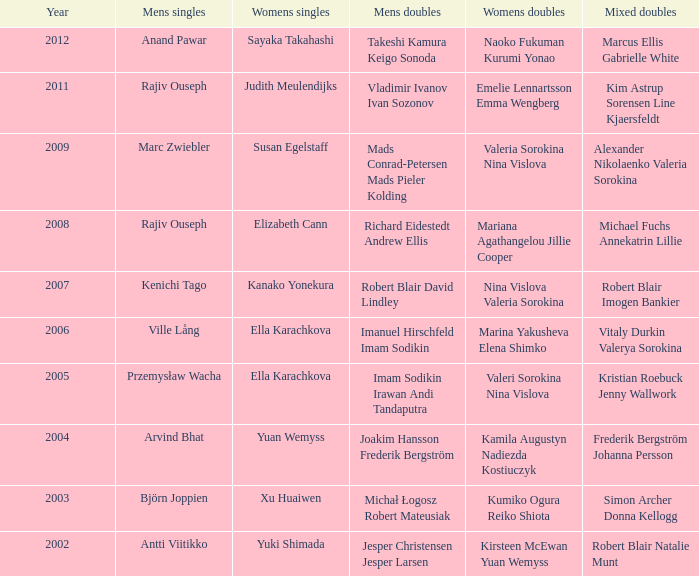Name the men's singles of marina yakusheva elena shimko Ville Lång. 